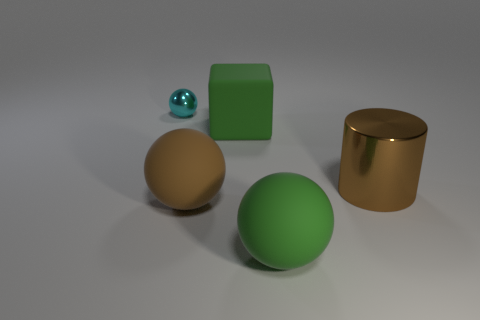Is the material of the tiny object the same as the large sphere right of the big green block?
Provide a succinct answer. No. There is a metal object that is on the right side of the cyan shiny object; is it the same color as the small object?
Your response must be concise. No. There is a object that is behind the metallic cylinder and in front of the tiny metallic ball; what material is it?
Make the answer very short. Rubber. The metal cylinder has what size?
Your answer should be very brief. Large. Do the block and the metallic object that is behind the big metal cylinder have the same color?
Keep it short and to the point. No. What number of other objects are there of the same color as the large metallic cylinder?
Ensure brevity in your answer.  1. There is a metallic object that is behind the large metallic thing; is it the same size as the green thing that is behind the big brown rubber ball?
Your answer should be compact. No. What color is the big rubber object behind the cylinder?
Your answer should be very brief. Green. Are there fewer big metallic objects right of the brown metal thing than large brown objects?
Provide a succinct answer. Yes. Does the big brown sphere have the same material as the small cyan sphere?
Your response must be concise. No. 